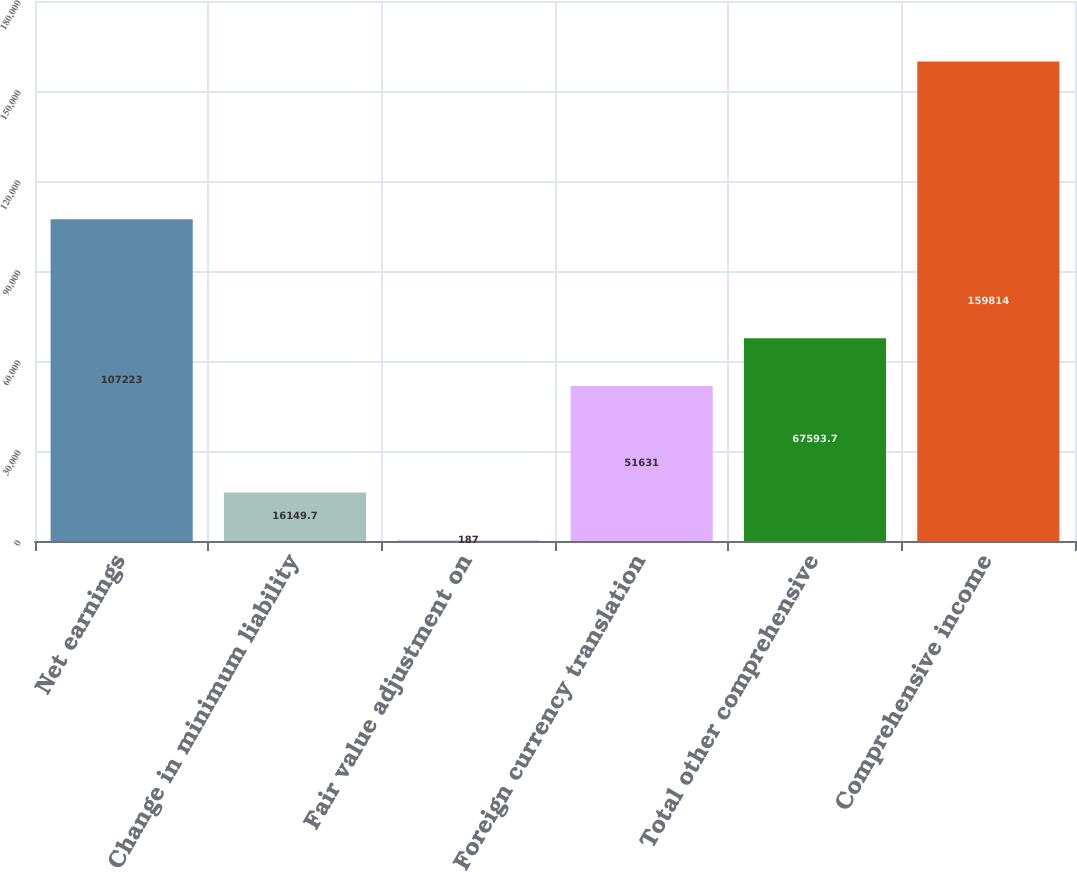Convert chart to OTSL. <chart><loc_0><loc_0><loc_500><loc_500><bar_chart><fcel>Net earnings<fcel>Change in minimum liability<fcel>Fair value adjustment on<fcel>Foreign currency translation<fcel>Total other comprehensive<fcel>Comprehensive income<nl><fcel>107223<fcel>16149.7<fcel>187<fcel>51631<fcel>67593.7<fcel>159814<nl></chart> 